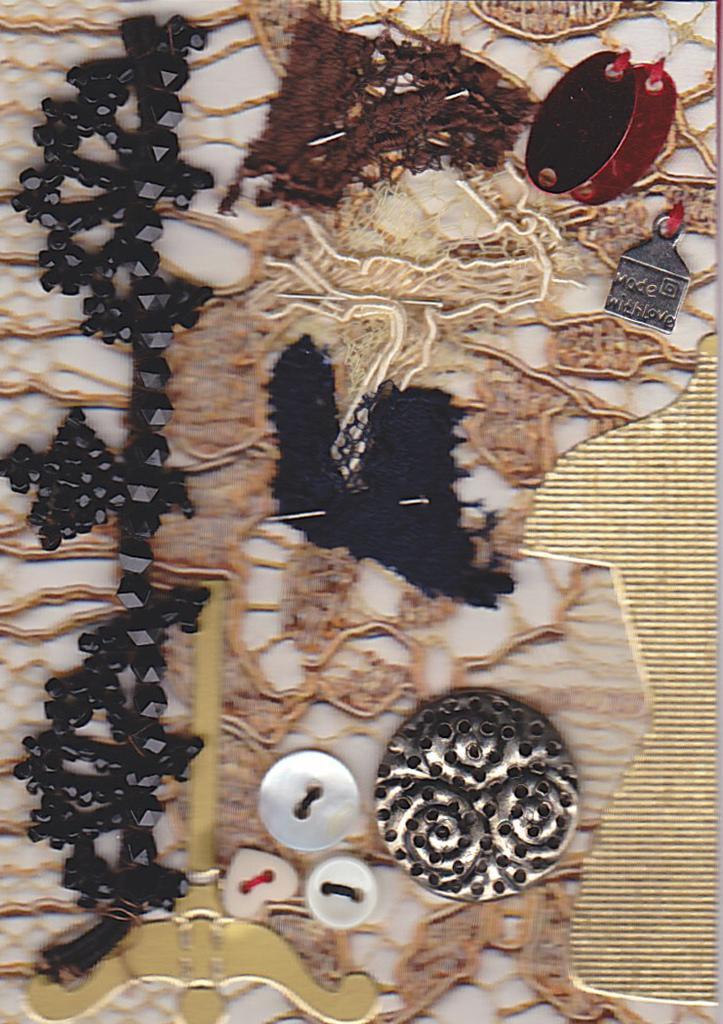In one or two sentences, can you explain what this image depicts? In this picture we can see there are buttons, pins and some objects. 